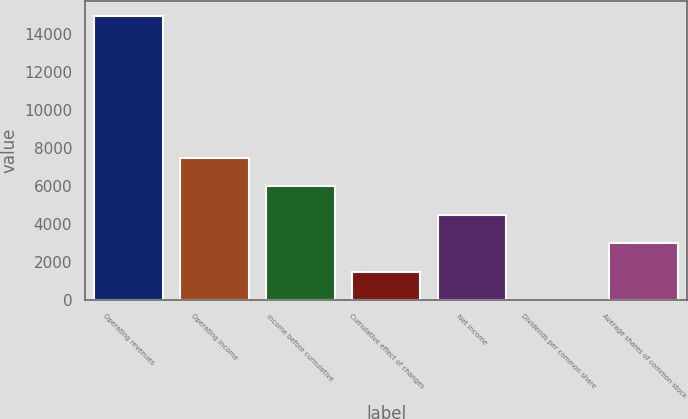<chart> <loc_0><loc_0><loc_500><loc_500><bar_chart><fcel>Operating revenues<fcel>Operating income<fcel>Income before cumulative<fcel>Cumulative effect of changes<fcel>Net income<fcel>Dividends per common share<fcel>Average shares of common stock<nl><fcel>14955<fcel>7477.93<fcel>5982.52<fcel>1496.29<fcel>4487.11<fcel>0.88<fcel>2991.7<nl></chart> 